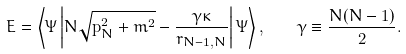<formula> <loc_0><loc_0><loc_500><loc_500>E = \left \langle \Psi \left | N \sqrt { { \mathbf p } _ { N } ^ { 2 } + m ^ { 2 } } - \frac { \gamma \kappa } { r _ { N - 1 , N } } \right | \Psi \right \rangle , \quad \gamma \equiv \frac { N ( N - 1 ) } { 2 } .</formula> 